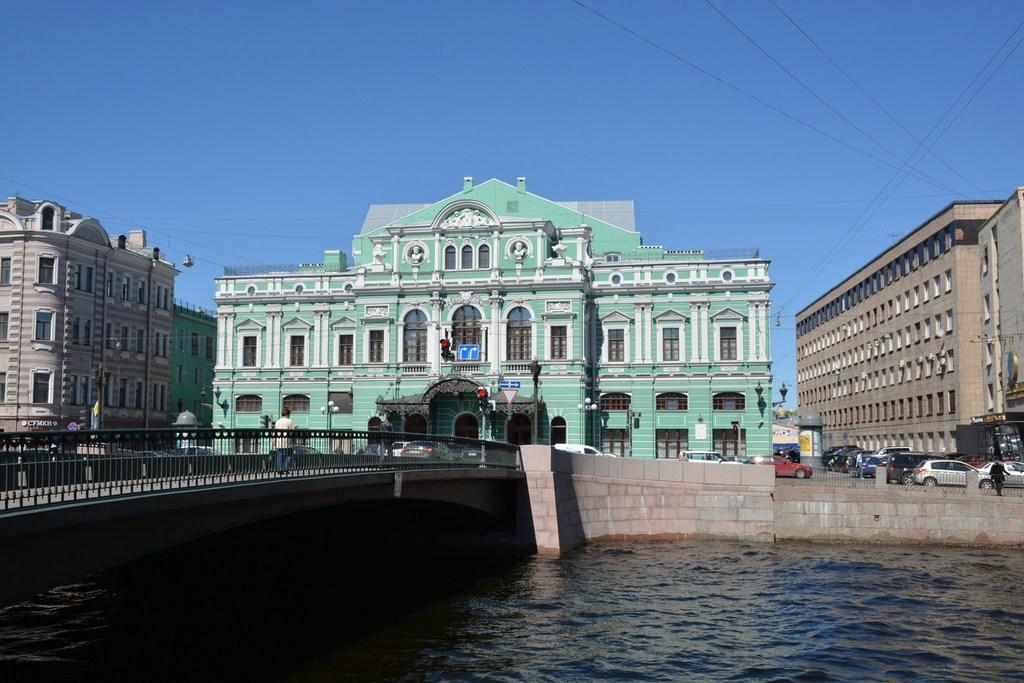What structure can be seen in the image? There is a bridge in the image. What else can be seen in the background of the image? Buildings are visible in the background are visible in the image. What type of transportation is present in the image? Vehicles are present on the road in the image. What part of the natural environment is visible in the image? The sky is visible in the image. What type of lace is being used to decorate the stage in the image? There is no stage or lace present in the image; it features a bridge, buildings, vehicles, and the sky. 